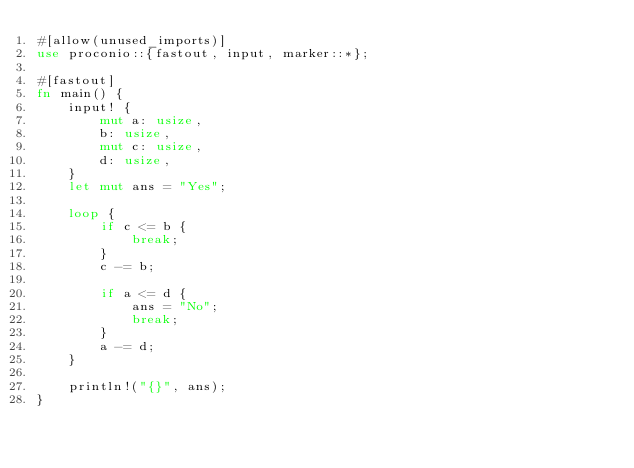Convert code to text. <code><loc_0><loc_0><loc_500><loc_500><_Rust_>#[allow(unused_imports)]
use proconio::{fastout, input, marker::*};

#[fastout]
fn main() {
    input! {
        mut a: usize,
        b: usize,
        mut c: usize,
        d: usize,
    }
    let mut ans = "Yes";

    loop {
        if c <= b {
            break;
        }
        c -= b;

        if a <= d {
            ans = "No";
            break;
        }
        a -= d;
    }

    println!("{}", ans);
}
</code> 